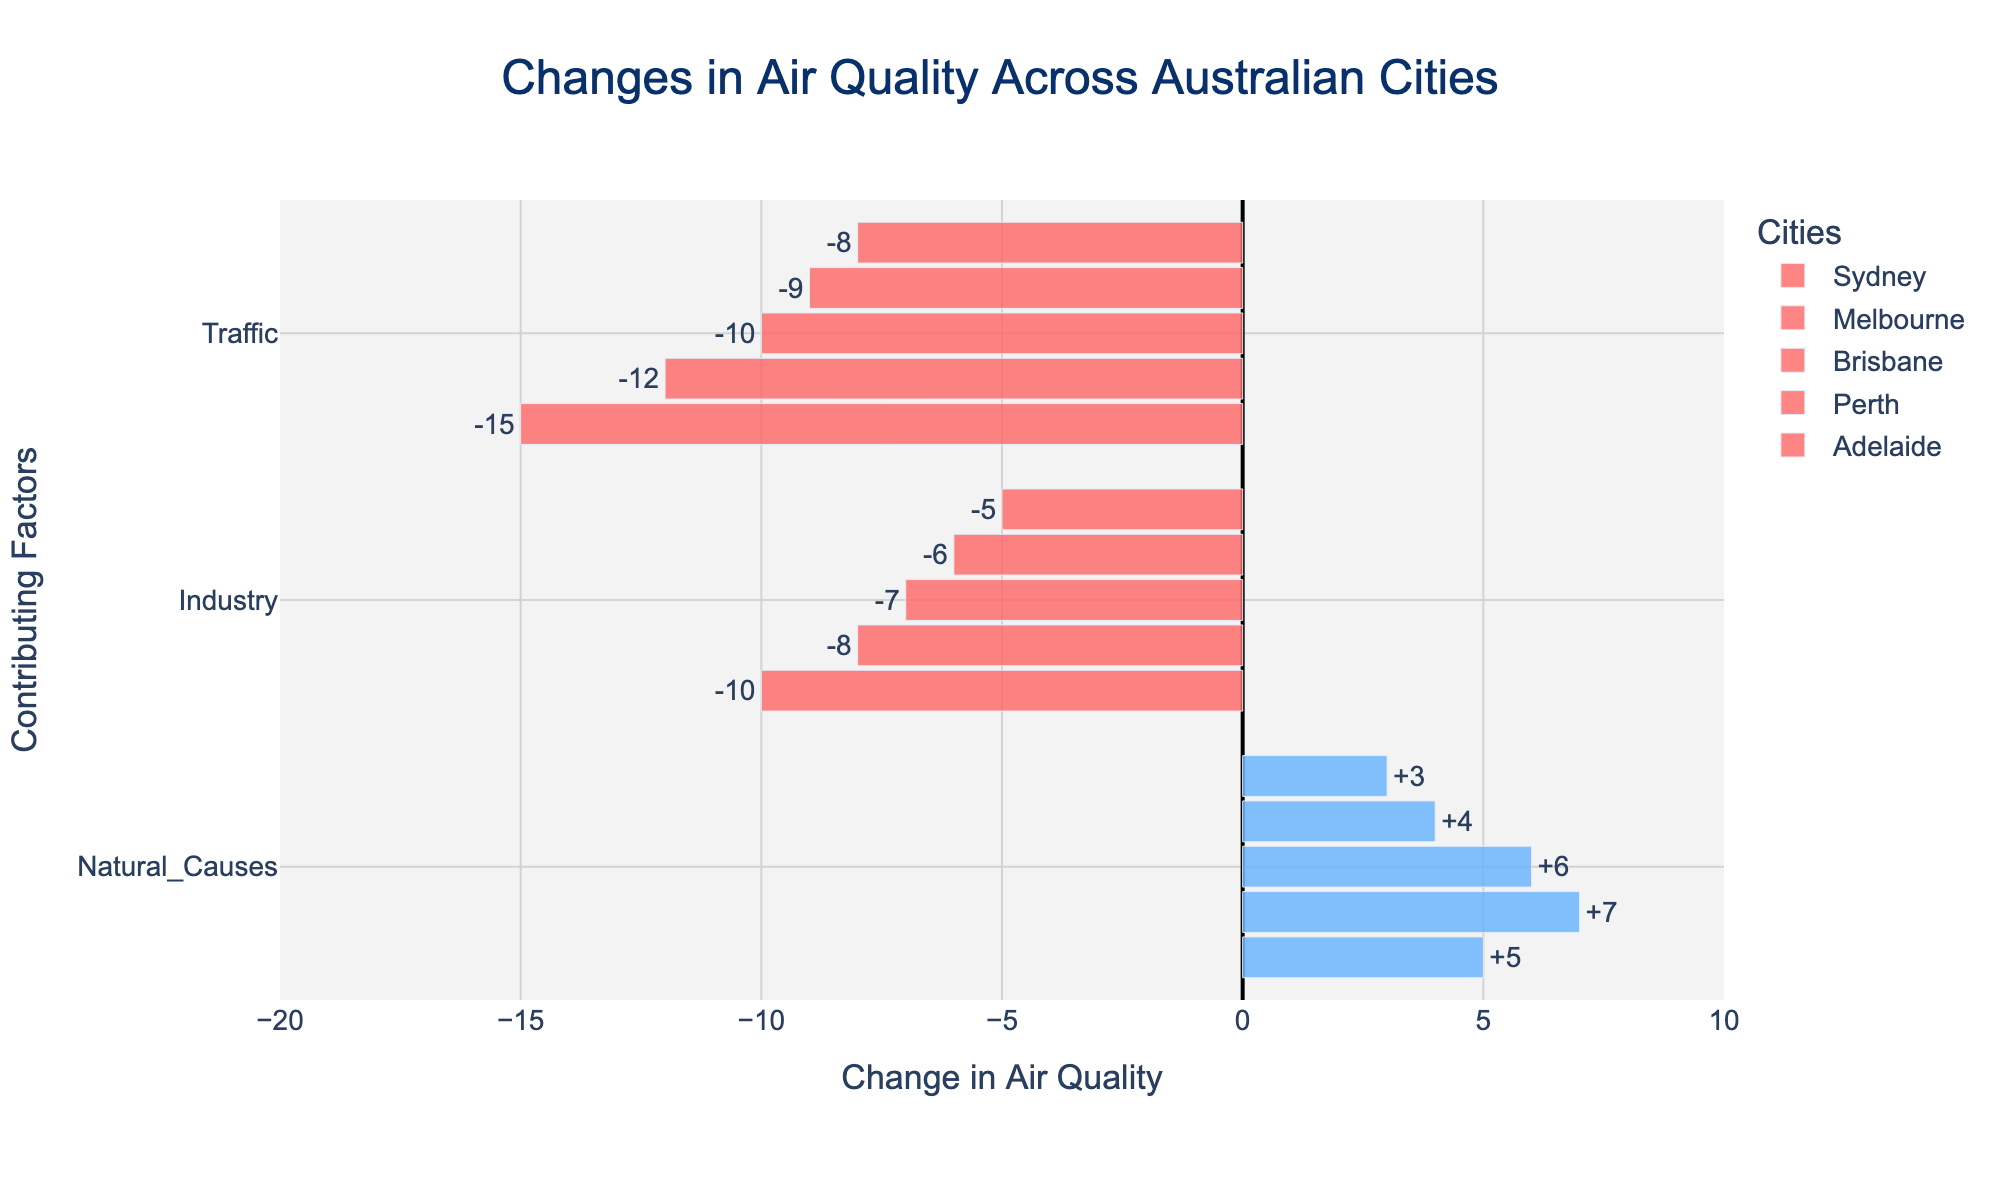What is the maximum positive change in air quality due to natural causes? To find the maximum positive change in air quality due to natural causes, look at the bars for the 'Natural Causes' factor across all cities and identify the highest number. The values are 5 (Sydney), 7 (Melbourne), 6 (Brisbane), 4 (Perth), and 3 (Adelaide). The maximum value is 7 in Melbourne.
Answer: 7 Which city experienced the largest negative impact on air quality due to traffic? To identify the city with the largest negative impact on air quality due to traffic, look at the bars for the 'Traffic' factor across all cities and find the most negative value. The values are -15 (Sydney), -12 (Melbourne), -10 (Brisbane), -9 (Perth), and -8 (Adelaide). The most negative value is -15 in Sydney.
Answer: Sydney Compare the impact of industry on air quality between Sydney and Melbourne. Which city is more negatively affected? Compare the bars for the 'Industry' factor between Sydney and Melbourne. The value for Sydney is -10, and for Melbourne, it is -8. Since -10 is more negative than -8, Sydney is more negatively affected by industry.
Answer: Sydney What is the overall net change in air quality across all factors in Brisbane? Sum the changes in air quality for all factors in Brisbane. The values are -10 (Traffic), -7 (Industry), and 6 (Natural Causes). The net change is -10 + (-7) + 6 = -11.
Answer: -11 Which factor generally has the highest negative impact on air quality across all cities? To determine which factor generally has the highest negative impact, compare the average negative values of each factor across all cities. Traffic: average of (-15, -12, -10, -9, -8) = -10.8. Industry: average of (-10, -8, -7, -6, -5) = -7.2. Natural Causes has positive values, so it's excluded. Traffic has the highest negative impact on average.
Answer: Traffic In which city does natural causes improve air quality the most? Check the bars for the 'Natural Causes' factor to see where the highest positive value is. The values are 5 (Sydney), 7 (Melbourne), 6 (Brisbane), 4 (Perth), and 3 (Adelaide). The highest value is 7 in Melbourne.
Answer: Melbourne What is the difference in the impact of traffic on air quality between Melbourne and Perth? Subtract the 'Traffic' factor values between Melbourne and Perth. Melbourne has -12, and Perth has -9. The difference is -12 - (-9) = -3.
Answer: -3 How does the air quality change due to industry in Sydney compare visually to that in Brisbane? Look at the length and color intensity of the bars for the 'Industry' factor in Sydney and Brisbane. Both are negative (red) bars. Sydney has a longer bar at -10, indicating a more significant negative impact compared to Brisbane's shorter bar at -7.
Answer: Sydney's air quality is more negatively impacted by industry than Brisbane’s What is the cumulative impact of natural causes on air quality across all cities? Sum the changes in air quality due to Natural Causes for all cities. The values are 5 (Sydney), 7 (Melbourne), 6 (Brisbane), 4 (Perth), and 3 (Adelaide). The total is 5 + 7 + 6 + 4 + 3 = 25.
Answer: 25 Is there any factor that improves air quality in all cities? Check the values for each factor across all cities. Only 'Natural Causes' has positive values (5, 7, 6, 4, 3) in all cities, whereas 'Traffic' and 'Industry' have negative impacts in all cases.
Answer: Natural Causes 